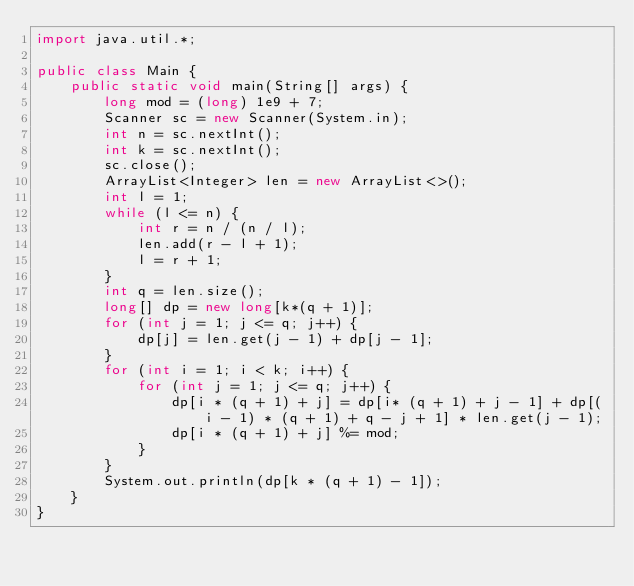Convert code to text. <code><loc_0><loc_0><loc_500><loc_500><_Java_>import java.util.*;

public class Main {
    public static void main(String[] args) {
        long mod = (long) 1e9 + 7;
        Scanner sc = new Scanner(System.in);
        int n = sc.nextInt();
        int k = sc.nextInt();
        sc.close();
        ArrayList<Integer> len = new ArrayList<>();
        int l = 1;
        while (l <= n) {
            int r = n / (n / l);
            len.add(r - l + 1);
            l = r + 1;
        }
        int q = len.size();
        long[] dp = new long[k*(q + 1)];
        for (int j = 1; j <= q; j++) {
            dp[j] = len.get(j - 1) + dp[j - 1];
        }
        for (int i = 1; i < k; i++) {
            for (int j = 1; j <= q; j++) {
                dp[i * (q + 1) + j] = dp[i* (q + 1) + j - 1] + dp[(i - 1) * (q + 1) + q - j + 1] * len.get(j - 1);
                dp[i * (q + 1) + j] %= mod;
            }
        }
        System.out.println(dp[k * (q + 1) - 1]);
    }
}
</code> 